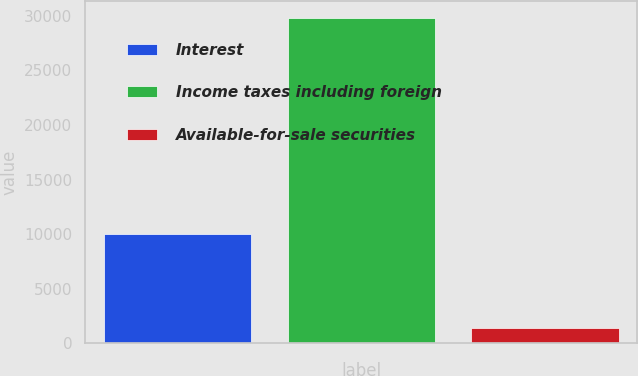Convert chart to OTSL. <chart><loc_0><loc_0><loc_500><loc_500><bar_chart><fcel>Interest<fcel>Income taxes including foreign<fcel>Available-for-sale securities<nl><fcel>9979<fcel>29838<fcel>1431<nl></chart> 